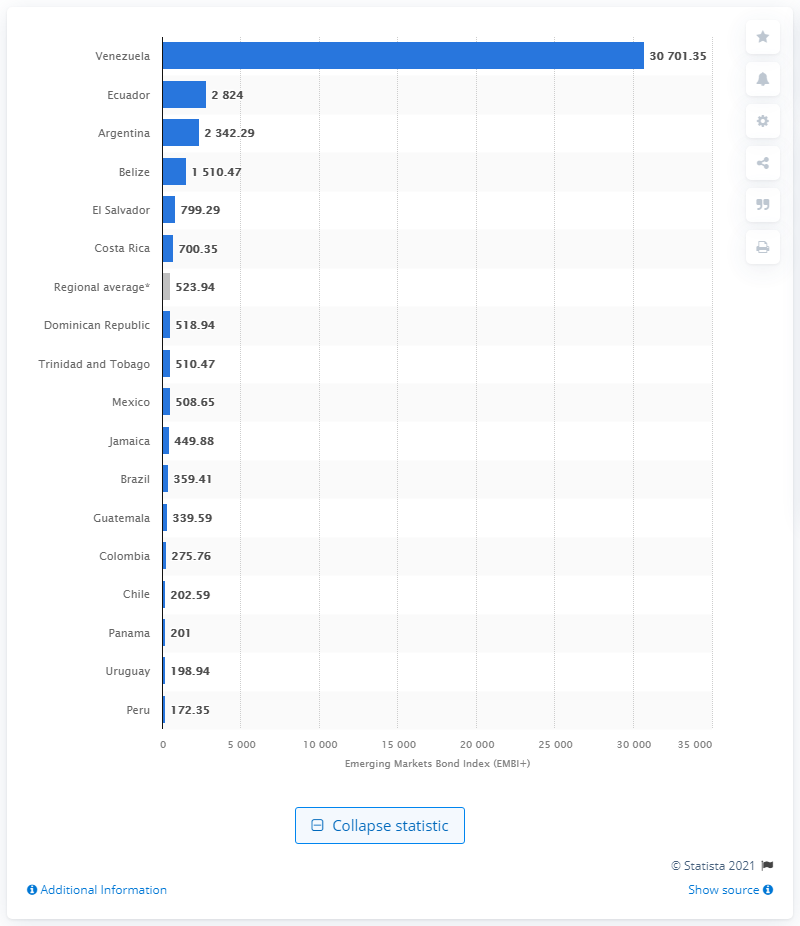Highlight a few significant elements in this photo. Venezuela was followed by Ecuador in the EMBI index. 